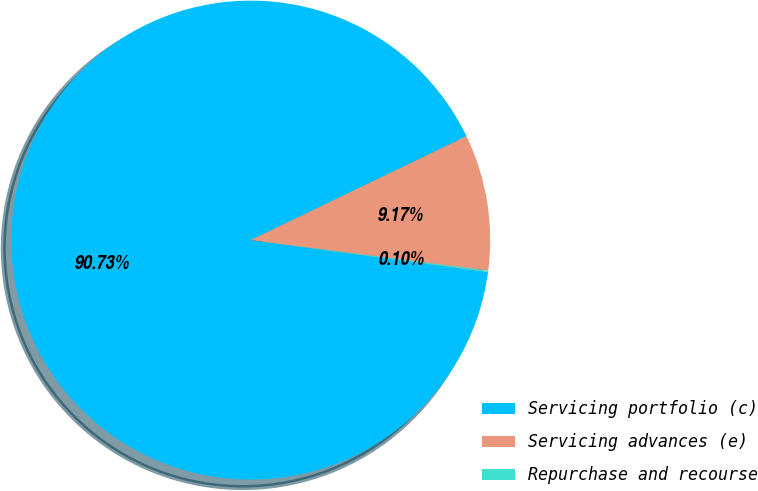<chart> <loc_0><loc_0><loc_500><loc_500><pie_chart><fcel>Servicing portfolio (c)<fcel>Servicing advances (e)<fcel>Repurchase and recourse<nl><fcel>90.73%<fcel>9.17%<fcel>0.1%<nl></chart> 